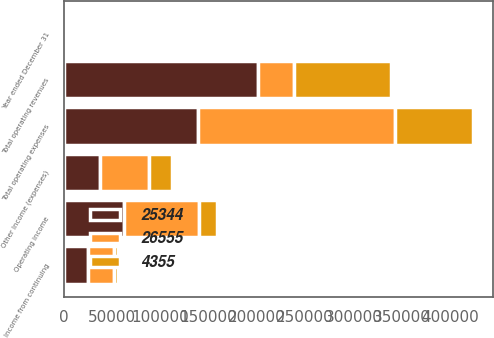<chart> <loc_0><loc_0><loc_500><loc_500><stacked_bar_chart><ecel><fcel>Year ended December 31<fcel>Total operating revenues<fcel>Total operating expenses<fcel>Operating income<fcel>Other Income (expenses)<fcel>Income from continuing<nl><fcel>26555<fcel>2006<fcel>37471<fcel>204349<fcel>77554<fcel>50999<fcel>26555<nl><fcel>25344<fcel>2005<fcel>201431<fcel>138616<fcel>62815<fcel>37471<fcel>25344<nl><fcel>4355<fcel>2004<fcel>99873<fcel>80944<fcel>18929<fcel>23284<fcel>4355<nl></chart> 